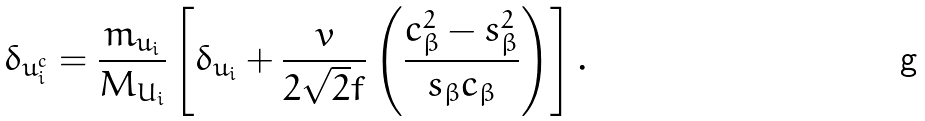<formula> <loc_0><loc_0><loc_500><loc_500>\delta _ { u _ { i } ^ { c } } = \frac { m _ { u _ { i } } } { M _ { U _ { i } } } \left [ \delta _ { u _ { i } } + \frac { v } { 2 \sqrt { 2 } f } \left ( \frac { c _ { \beta } ^ { 2 } - s _ { \beta } ^ { 2 } } { s _ { \beta } c _ { \beta } } \right ) \right ] .</formula> 